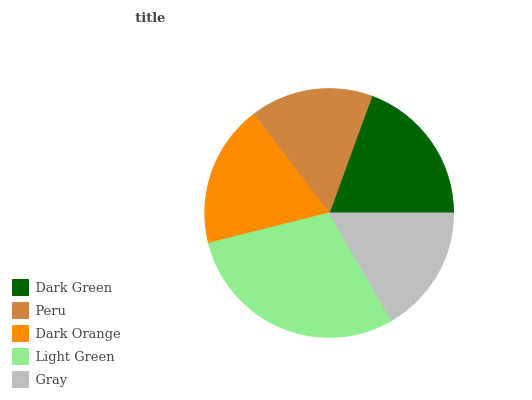Is Peru the minimum?
Answer yes or no. Yes. Is Light Green the maximum?
Answer yes or no. Yes. Is Dark Orange the minimum?
Answer yes or no. No. Is Dark Orange the maximum?
Answer yes or no. No. Is Dark Orange greater than Peru?
Answer yes or no. Yes. Is Peru less than Dark Orange?
Answer yes or no. Yes. Is Peru greater than Dark Orange?
Answer yes or no. No. Is Dark Orange less than Peru?
Answer yes or no. No. Is Dark Orange the high median?
Answer yes or no. Yes. Is Dark Orange the low median?
Answer yes or no. Yes. Is Gray the high median?
Answer yes or no. No. Is Dark Green the low median?
Answer yes or no. No. 